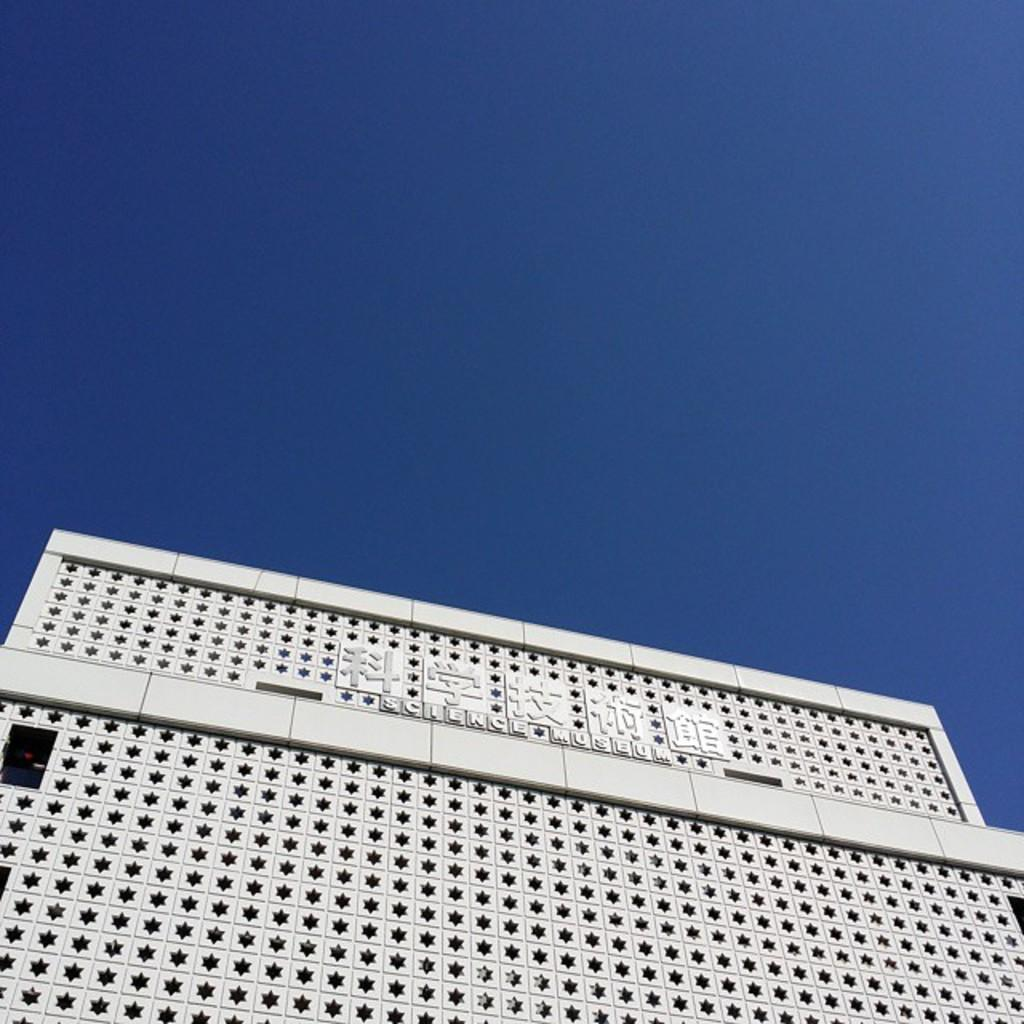What is the main structure in the picture? There is a building in the picture. Are there any words or symbols on the building? Yes, there is writing on the building. What color is the sky in the picture? The sky is blue in the picture. Can you tell me how many babies are crawling on the building in the image? There are no babies present in the image; it only features a building with writing on it and a blue sky. What type of error can be seen on the building? There is no error present on the building in the image. 